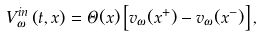Convert formula to latex. <formula><loc_0><loc_0><loc_500><loc_500>V _ { \omega } ^ { i n } \left ( t , x \right ) = \Theta ( x ) \left [ v _ { \omega } ( x ^ { + } ) - v _ { \omega } ( x ^ { - } ) \right ] ,</formula> 